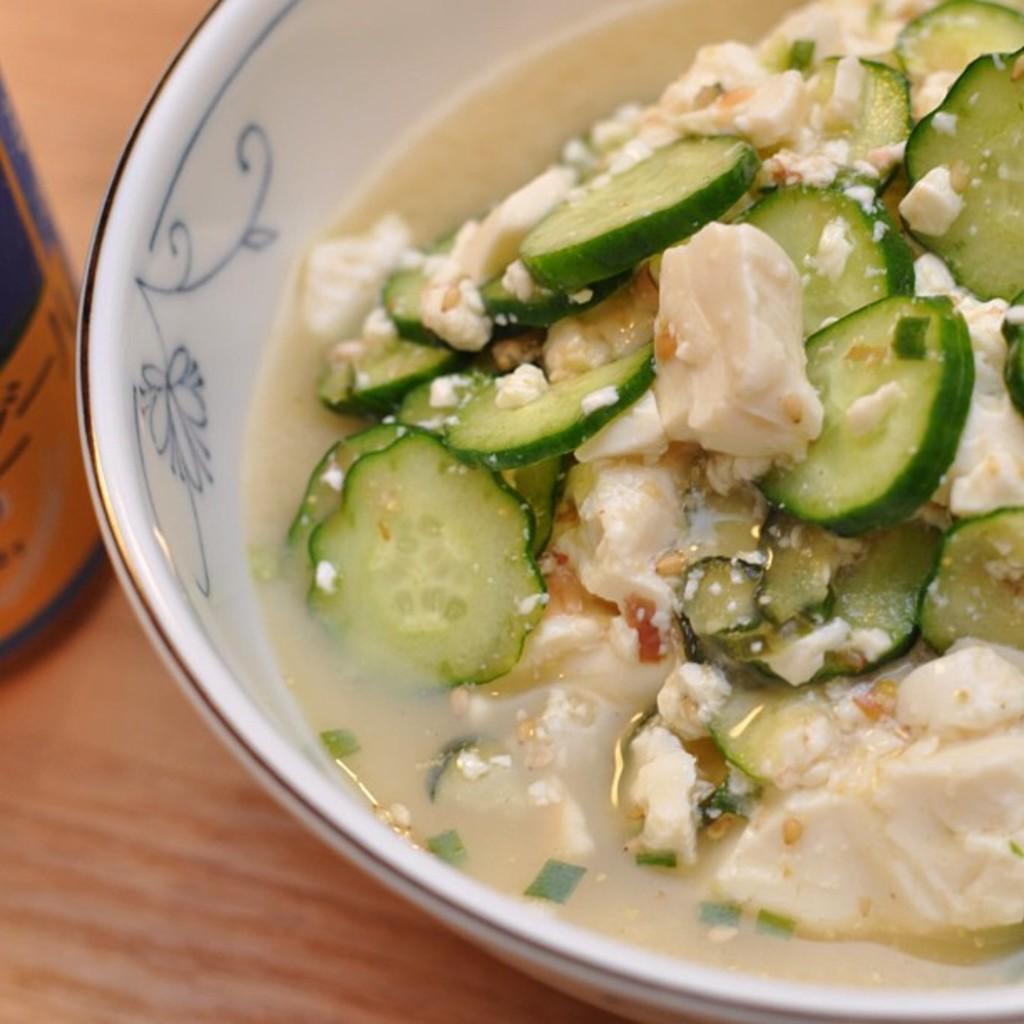Please provide a concise description of this image. In this image there is some food kept in a white color bowl as we can see at right side of this image and there is one object at left side of this image. 